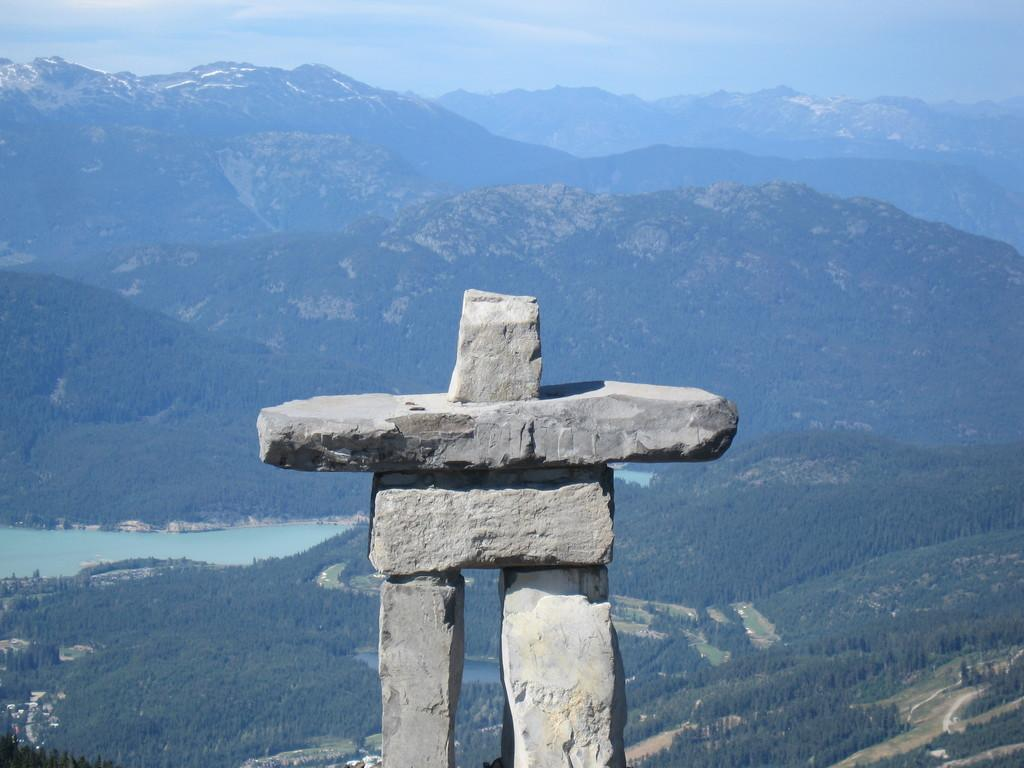What is the main subject in the foreground of the image? There is a stone structure in the foreground of the image. What can be seen in the background of the image? There are trees, water, mountains, and the sky visible in the background of the image. What type of learning is taking place in the image? There is no indication of any learning activity taking place in the image. 